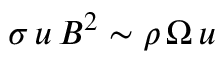<formula> <loc_0><loc_0><loc_500><loc_500>\sigma \, u \, B ^ { 2 } \sim \rho \, \Omega \, u</formula> 